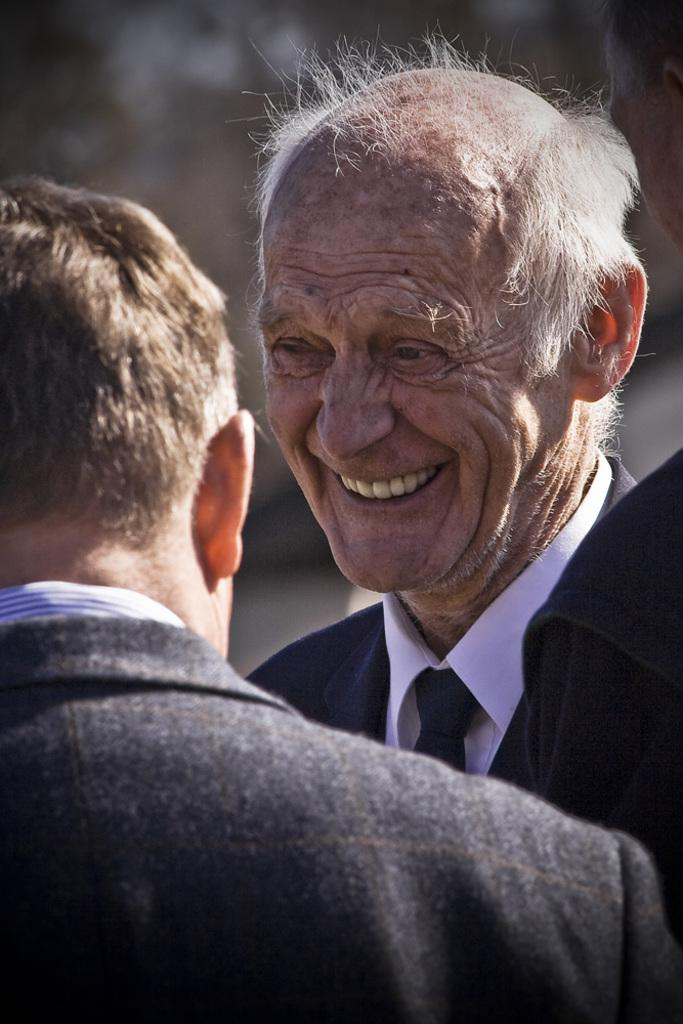How many people are in the image? There are two persons in the image. Can you describe the background of the image? The background of the image is blurred. How many trees can be seen in the image? There is no information about trees in the image, as the provided facts only mention two persons and a blurred background. 